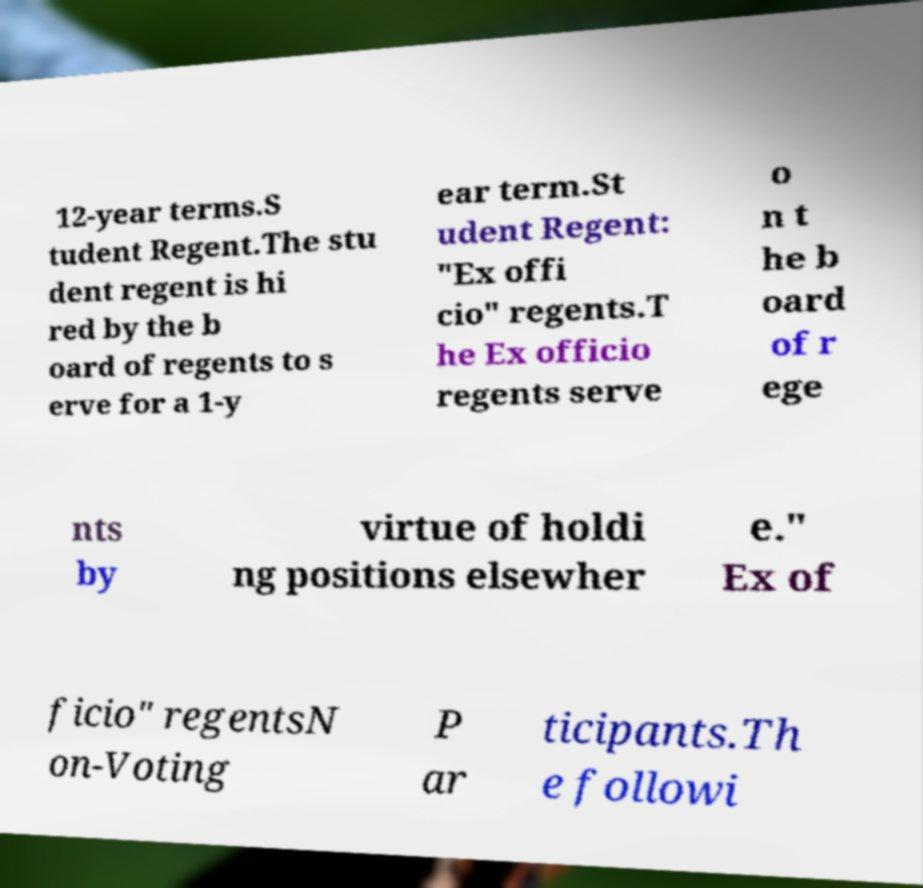Please read and relay the text visible in this image. What does it say? 12-year terms.S tudent Regent.The stu dent regent is hi red by the b oard of regents to s erve for a 1-y ear term.St udent Regent: "Ex offi cio" regents.T he Ex officio regents serve o n t he b oard of r ege nts by virtue of holdi ng positions elsewher e." Ex of ficio" regentsN on-Voting P ar ticipants.Th e followi 